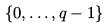Convert formula to latex. <formula><loc_0><loc_0><loc_500><loc_500>\{ 0 , \dots , q - 1 \}</formula> 